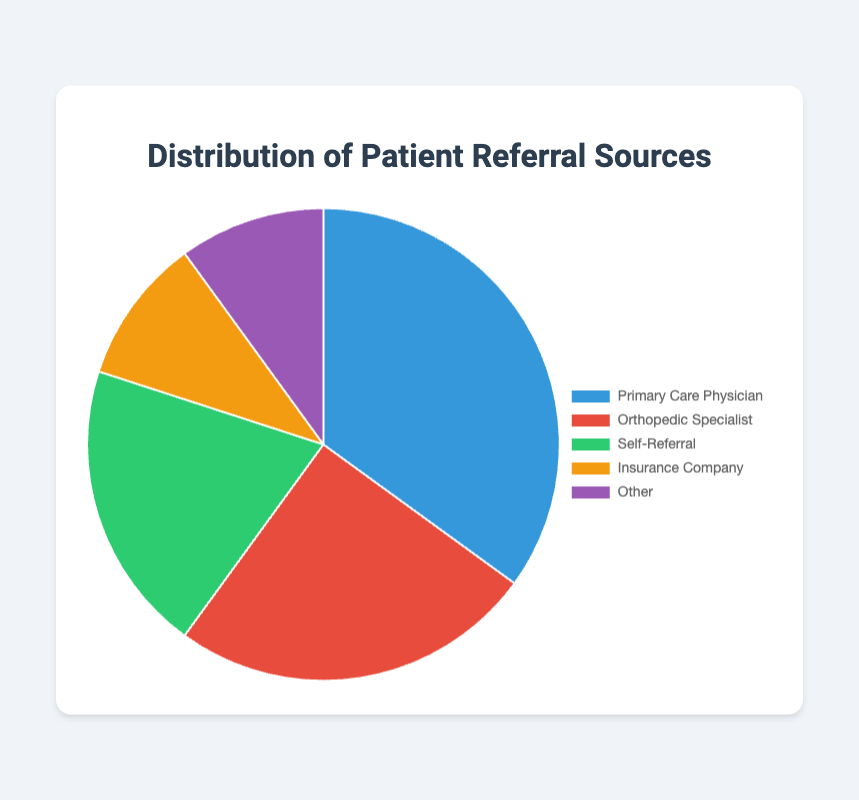What is the most common patient referral source? The segment with the largest slice represents the most common patient referral source. In this pie chart, the largest slice is labeled "Primary Care Physician" and represents 35% of referrals.
Answer: Primary Care Physician Which two referral sources contribute equally to the clinic's patient referrals? The pie chart shows that "Insurance Company" and "Other" both have slices representing 10% of the patient referrals each.
Answer: Insurance Company and Other What is the total percentage of patient referrals from specialists? To find the total percentage from specialists, sum the percentages for "Primary Care Physician" and "Orthopedic Specialist." That's 35% + 25% = 60%.
Answer: 60% How much greater is the percentage of referrals from self-referrals compared to those from insurance companies? Subtract the percentage of insurance company referrals from self-referrals: 20% - 10% = 10%.
Answer: 10% Which referral source has the second-highest percentage, and what is the percentage? The second-largest slice in the pie chart is labeled "Orthopedic Specialist," which represents 25% of referrals.
Answer: Orthopedic Specialist, 25% What is the combined percentage of referrals from self-referral and other sources? Add the percentages of self-referral and other sources: 20% + 10% = 30%.
Answer: 30% Which referral source is represented by the green slice in the pie chart? Looking at the color legend, the green slice corresponds to "Self-Referral."
Answer: Self-Referral What fraction of the clinic's patients is referred by primary care physicians? Primary care physicians refer 35% of patients. The fraction form is 35/100, which simplifies to 7/20.
Answer: 7/20 Is the percentage of referrals from insurance companies greater or less than self-referrals, and by how much? Compare the percentages of insurance company referrals (10%) and self-referrals (20%). Subtract 10% from 20%: 20% - 10% = 10%.
Answer: Less by 10% 